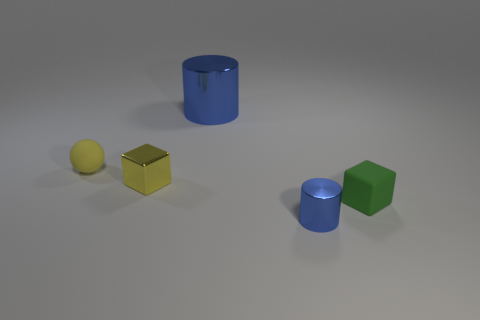Add 3 small yellow objects. How many objects exist? 8 Subtract all spheres. How many objects are left? 4 Add 5 shiny cylinders. How many shiny cylinders are left? 7 Add 4 balls. How many balls exist? 5 Subtract 0 brown cylinders. How many objects are left? 5 Subtract all red metallic spheres. Subtract all green rubber objects. How many objects are left? 4 